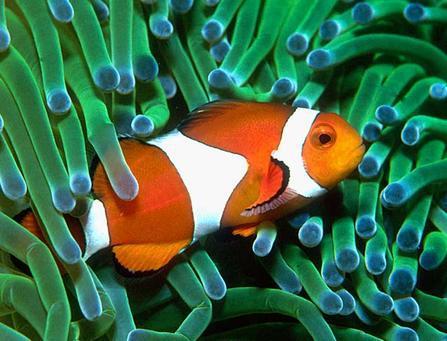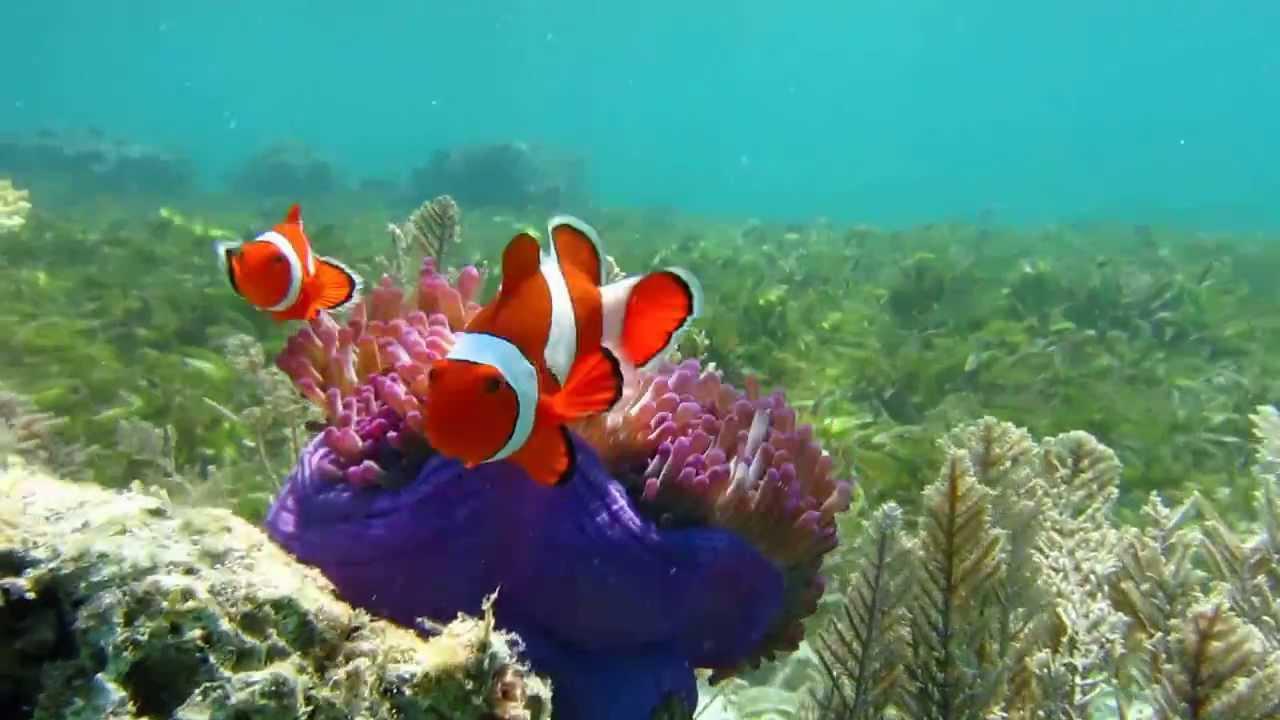The first image is the image on the left, the second image is the image on the right. Evaluate the accuracy of this statement regarding the images: "There are two fish in the picture on the left.". Is it true? Answer yes or no. No. 